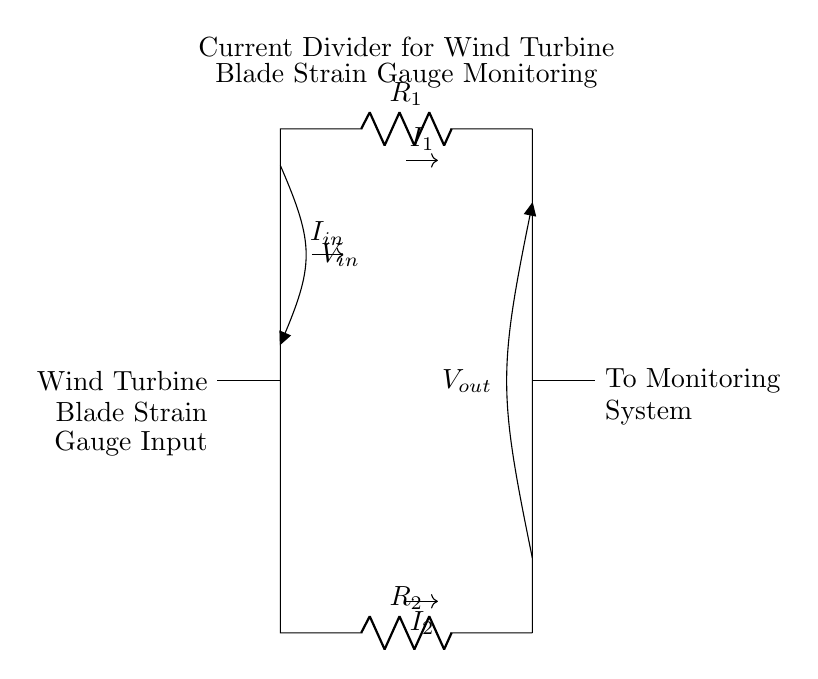What is the input voltage of this circuit? The input voltage, denoted as V_in, is marked in the circuit diagram. It is the voltage supplied to the current divider from the wind turbine's blade strain gauge system.
Answer: V_in What are the resistors in the circuit? The circuit features two resistors labeled R_1 and R_2. These components are essential for the current division process in the circuit layout.
Answer: R_1 and R_2 What is the relationship between I_in, I_1, and I_2? In a current divider circuit, the input current I_in splits into two parts: I_1 and I_2. The division is based on the resistor values R_1 and R_2. Thus, I_in = I_1 + I_2, representing the principle of current conservation.
Answer: I_in = I_1 + I_2 Which component is used to monitor the strain gauges? The circuit diagram labels a connection to a monitoring system. This is where the outputs I_1 and I_2 provide the necessary data for analyzing the strain on the wind turbine blades.
Answer: Monitoring System What type of circuit is depicted in this diagram? This is a current divider circuit, specifically designed for measuring the current flow through different paths in relation to the wind turbine blade strain gauges. The arrangement illustrates how input current gets distributed across two resistors.
Answer: Current Divider How does the value of R_1 affect I_1? The current through resistor R_1, denoted as I_1, is inversely proportional to its resistance value in a current divider configuration. When R_1 increases, I_1 decreases, given a constant input current I_in. This relationship can be derived from Ohm's law and the current division rule.
Answer: Inversely proportional 